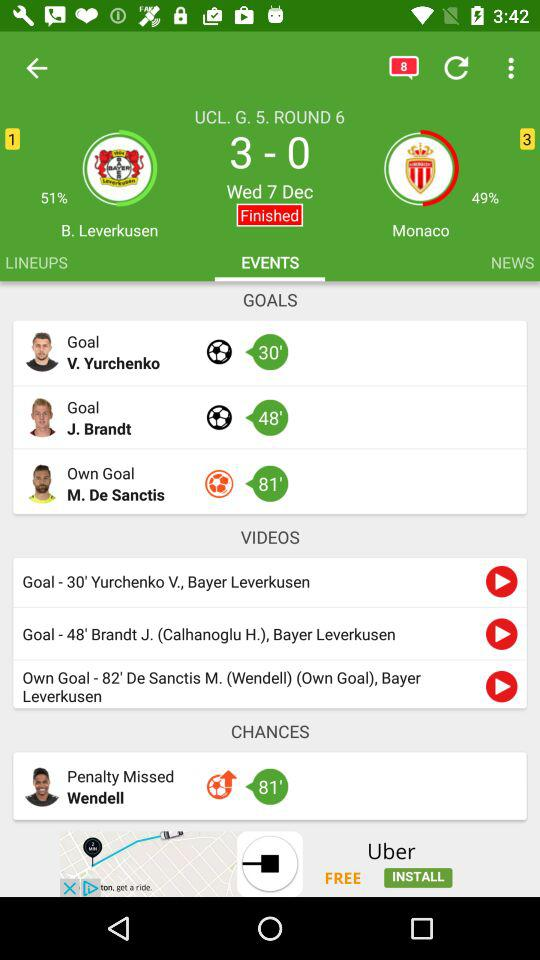When did the match occur? The match occurred on Wednesday, December 7. 